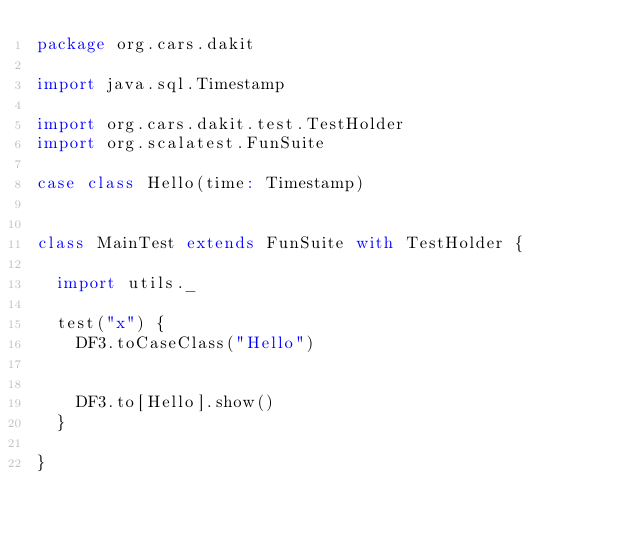<code> <loc_0><loc_0><loc_500><loc_500><_Scala_>package org.cars.dakit

import java.sql.Timestamp

import org.cars.dakit.test.TestHolder
import org.scalatest.FunSuite

case class Hello(time: Timestamp)


class MainTest extends FunSuite with TestHolder {

  import utils._

  test("x") {
    DF3.toCaseClass("Hello")


    DF3.to[Hello].show()
  }

}
</code> 